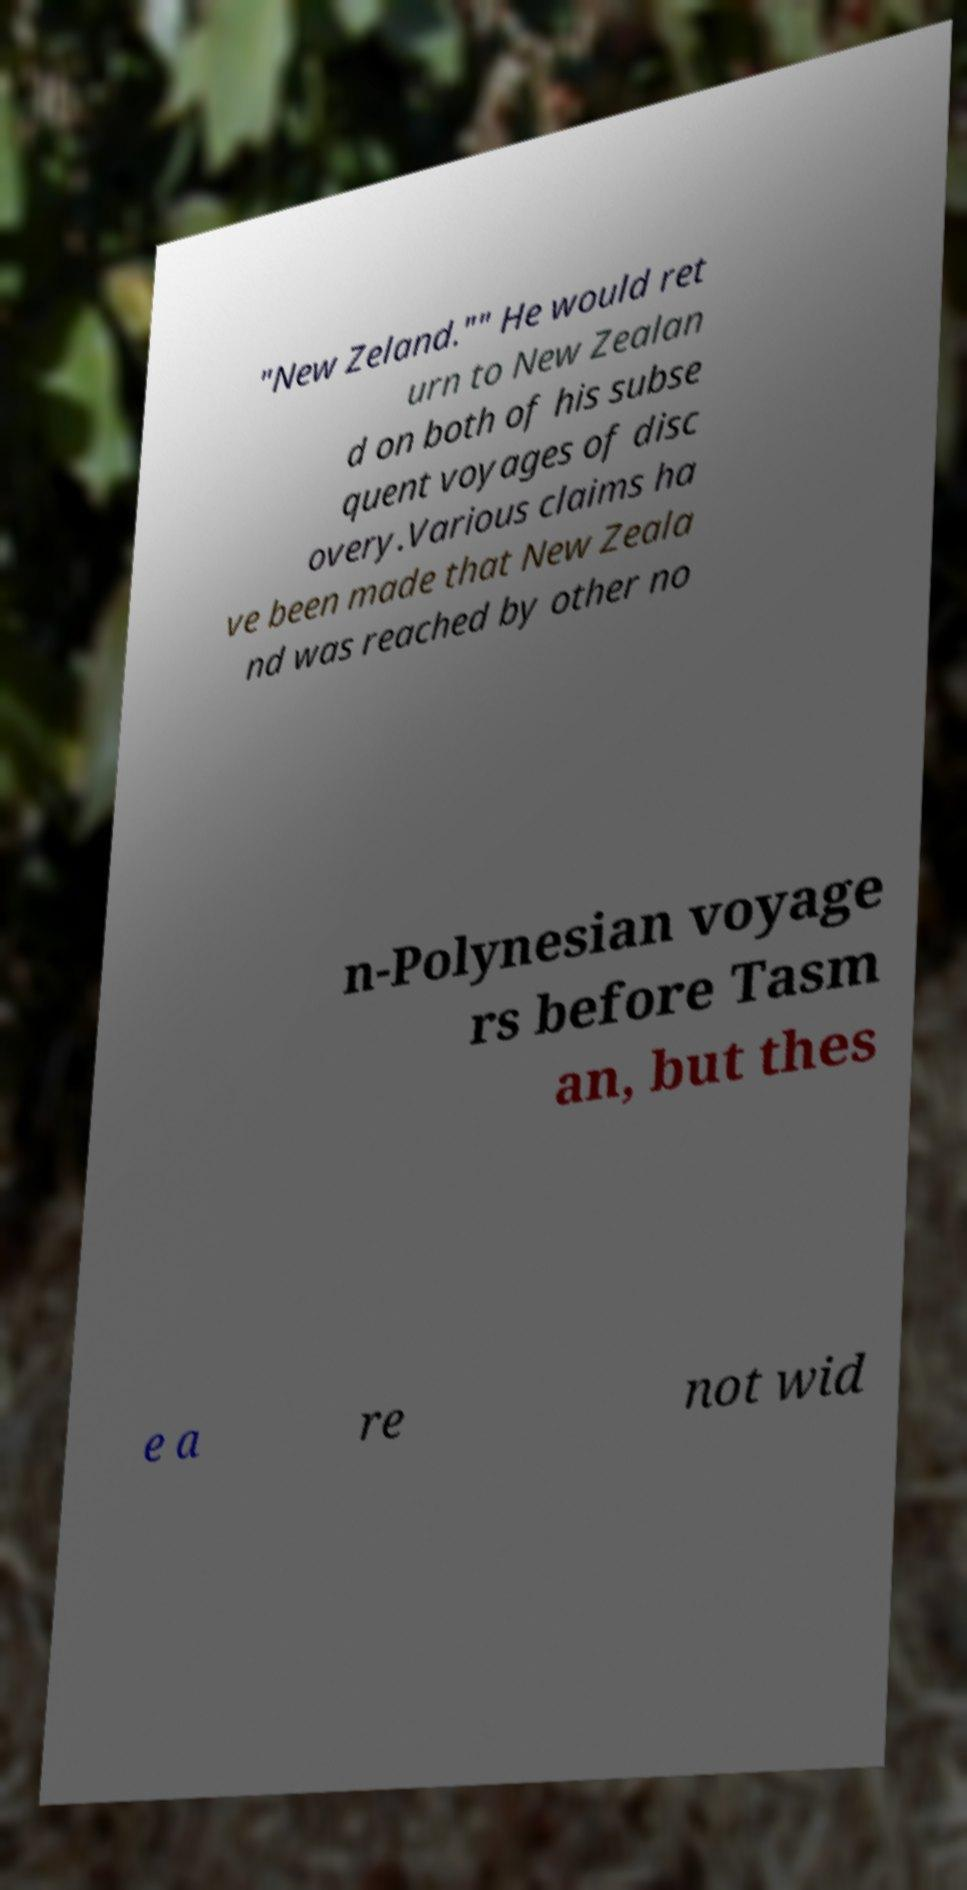For documentation purposes, I need the text within this image transcribed. Could you provide that? "New Zeland."" He would ret urn to New Zealan d on both of his subse quent voyages of disc overy.Various claims ha ve been made that New Zeala nd was reached by other no n-Polynesian voyage rs before Tasm an, but thes e a re not wid 